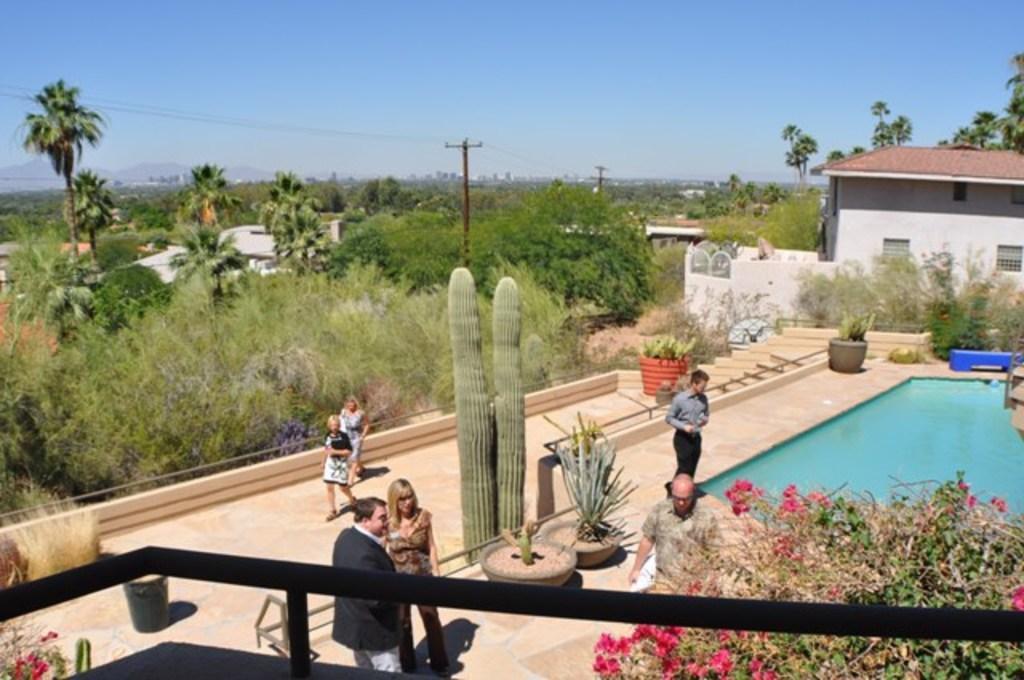Can you describe this image briefly? In this image we can see a group of people standing on the ground. In the center of the image we can see a cactus plant and we can also see some plants in pots. On the right side of the image we can see a swimming pool, bench, a group of flowers on plants, building with windows and roof. On the left side of the image we can see a group of trees and buildings. In the background, we can see some poles and the sky. 